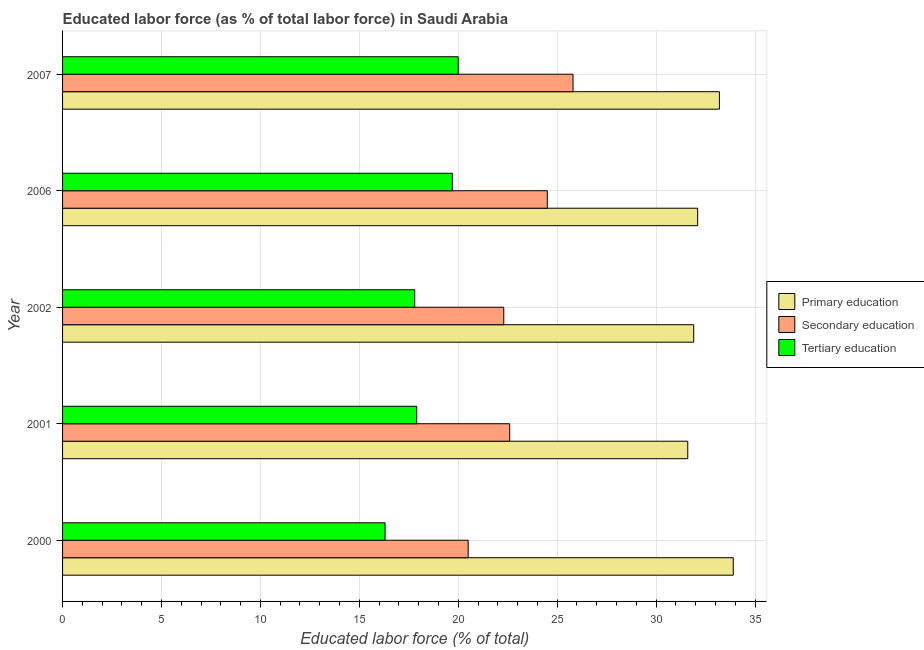Are the number of bars on each tick of the Y-axis equal?
Make the answer very short. Yes. How many bars are there on the 3rd tick from the bottom?
Offer a terse response. 3. In how many cases, is the number of bars for a given year not equal to the number of legend labels?
Offer a terse response. 0. What is the percentage of labor force who received secondary education in 2006?
Give a very brief answer. 24.5. Across all years, what is the maximum percentage of labor force who received secondary education?
Your answer should be very brief. 25.8. Across all years, what is the minimum percentage of labor force who received tertiary education?
Provide a succinct answer. 16.3. In which year was the percentage of labor force who received tertiary education minimum?
Your response must be concise. 2000. What is the total percentage of labor force who received secondary education in the graph?
Your answer should be compact. 115.7. What is the difference between the percentage of labor force who received tertiary education in 2000 and that in 2001?
Provide a succinct answer. -1.6. What is the difference between the percentage of labor force who received primary education in 2001 and the percentage of labor force who received tertiary education in 2007?
Your answer should be very brief. 11.6. What is the average percentage of labor force who received primary education per year?
Give a very brief answer. 32.54. In how many years, is the percentage of labor force who received primary education greater than 27 %?
Your answer should be very brief. 5. What is the ratio of the percentage of labor force who received tertiary education in 2001 to that in 2006?
Your response must be concise. 0.91. Is the difference between the percentage of labor force who received secondary education in 2001 and 2002 greater than the difference between the percentage of labor force who received tertiary education in 2001 and 2002?
Give a very brief answer. Yes. What is the difference between the highest and the second highest percentage of labor force who received primary education?
Offer a terse response. 0.7. What is the difference between the highest and the lowest percentage of labor force who received tertiary education?
Provide a succinct answer. 3.7. What does the 2nd bar from the top in 2002 represents?
Offer a terse response. Secondary education. What does the 3rd bar from the bottom in 2002 represents?
Provide a short and direct response. Tertiary education. Is it the case that in every year, the sum of the percentage of labor force who received primary education and percentage of labor force who received secondary education is greater than the percentage of labor force who received tertiary education?
Your answer should be compact. Yes. How many bars are there?
Keep it short and to the point. 15. What is the difference between two consecutive major ticks on the X-axis?
Offer a very short reply. 5. Are the values on the major ticks of X-axis written in scientific E-notation?
Ensure brevity in your answer.  No. Does the graph contain any zero values?
Your answer should be very brief. No. How many legend labels are there?
Your answer should be compact. 3. How are the legend labels stacked?
Ensure brevity in your answer.  Vertical. What is the title of the graph?
Ensure brevity in your answer.  Educated labor force (as % of total labor force) in Saudi Arabia. Does "Natural Gas" appear as one of the legend labels in the graph?
Your response must be concise. No. What is the label or title of the X-axis?
Offer a very short reply. Educated labor force (% of total). What is the label or title of the Y-axis?
Give a very brief answer. Year. What is the Educated labor force (% of total) of Primary education in 2000?
Your answer should be compact. 33.9. What is the Educated labor force (% of total) in Tertiary education in 2000?
Make the answer very short. 16.3. What is the Educated labor force (% of total) in Primary education in 2001?
Provide a succinct answer. 31.6. What is the Educated labor force (% of total) of Secondary education in 2001?
Give a very brief answer. 22.6. What is the Educated labor force (% of total) in Tertiary education in 2001?
Keep it short and to the point. 17.9. What is the Educated labor force (% of total) of Primary education in 2002?
Give a very brief answer. 31.9. What is the Educated labor force (% of total) in Secondary education in 2002?
Ensure brevity in your answer.  22.3. What is the Educated labor force (% of total) in Tertiary education in 2002?
Offer a terse response. 17.8. What is the Educated labor force (% of total) in Primary education in 2006?
Your answer should be very brief. 32.1. What is the Educated labor force (% of total) in Tertiary education in 2006?
Your response must be concise. 19.7. What is the Educated labor force (% of total) of Primary education in 2007?
Your response must be concise. 33.2. What is the Educated labor force (% of total) of Secondary education in 2007?
Your response must be concise. 25.8. Across all years, what is the maximum Educated labor force (% of total) of Primary education?
Offer a very short reply. 33.9. Across all years, what is the maximum Educated labor force (% of total) of Secondary education?
Your response must be concise. 25.8. Across all years, what is the maximum Educated labor force (% of total) of Tertiary education?
Your answer should be compact. 20. Across all years, what is the minimum Educated labor force (% of total) of Primary education?
Offer a very short reply. 31.6. Across all years, what is the minimum Educated labor force (% of total) in Secondary education?
Ensure brevity in your answer.  20.5. Across all years, what is the minimum Educated labor force (% of total) of Tertiary education?
Provide a succinct answer. 16.3. What is the total Educated labor force (% of total) in Primary education in the graph?
Offer a terse response. 162.7. What is the total Educated labor force (% of total) of Secondary education in the graph?
Give a very brief answer. 115.7. What is the total Educated labor force (% of total) in Tertiary education in the graph?
Your answer should be very brief. 91.7. What is the difference between the Educated labor force (% of total) of Tertiary education in 2000 and that in 2001?
Your answer should be very brief. -1.6. What is the difference between the Educated labor force (% of total) of Primary education in 2000 and that in 2002?
Offer a terse response. 2. What is the difference between the Educated labor force (% of total) in Primary education in 2000 and that in 2006?
Provide a succinct answer. 1.8. What is the difference between the Educated labor force (% of total) in Tertiary education in 2000 and that in 2006?
Keep it short and to the point. -3.4. What is the difference between the Educated labor force (% of total) of Primary education in 2000 and that in 2007?
Offer a terse response. 0.7. What is the difference between the Educated labor force (% of total) of Secondary education in 2000 and that in 2007?
Make the answer very short. -5.3. What is the difference between the Educated labor force (% of total) in Primary education in 2001 and that in 2002?
Provide a short and direct response. -0.3. What is the difference between the Educated labor force (% of total) of Secondary education in 2001 and that in 2002?
Offer a terse response. 0.3. What is the difference between the Educated labor force (% of total) of Tertiary education in 2001 and that in 2002?
Your response must be concise. 0.1. What is the difference between the Educated labor force (% of total) in Primary education in 2001 and that in 2006?
Keep it short and to the point. -0.5. What is the difference between the Educated labor force (% of total) in Primary education in 2001 and that in 2007?
Provide a short and direct response. -1.6. What is the difference between the Educated labor force (% of total) in Secondary education in 2001 and that in 2007?
Make the answer very short. -3.2. What is the difference between the Educated labor force (% of total) of Secondary education in 2002 and that in 2006?
Offer a terse response. -2.2. What is the difference between the Educated labor force (% of total) in Primary education in 2002 and that in 2007?
Your answer should be very brief. -1.3. What is the difference between the Educated labor force (% of total) of Secondary education in 2002 and that in 2007?
Offer a terse response. -3.5. What is the difference between the Educated labor force (% of total) in Secondary education in 2006 and that in 2007?
Make the answer very short. -1.3. What is the difference between the Educated labor force (% of total) in Tertiary education in 2006 and that in 2007?
Make the answer very short. -0.3. What is the difference between the Educated labor force (% of total) in Primary education in 2000 and the Educated labor force (% of total) in Secondary education in 2002?
Make the answer very short. 11.6. What is the difference between the Educated labor force (% of total) of Secondary education in 2000 and the Educated labor force (% of total) of Tertiary education in 2002?
Your answer should be compact. 2.7. What is the difference between the Educated labor force (% of total) in Primary education in 2000 and the Educated labor force (% of total) in Secondary education in 2006?
Your answer should be very brief. 9.4. What is the difference between the Educated labor force (% of total) in Secondary education in 2000 and the Educated labor force (% of total) in Tertiary education in 2006?
Your response must be concise. 0.8. What is the difference between the Educated labor force (% of total) of Primary education in 2000 and the Educated labor force (% of total) of Secondary education in 2007?
Provide a short and direct response. 8.1. What is the difference between the Educated labor force (% of total) in Primary education in 2000 and the Educated labor force (% of total) in Tertiary education in 2007?
Provide a short and direct response. 13.9. What is the difference between the Educated labor force (% of total) in Secondary education in 2000 and the Educated labor force (% of total) in Tertiary education in 2007?
Offer a terse response. 0.5. What is the difference between the Educated labor force (% of total) in Secondary education in 2001 and the Educated labor force (% of total) in Tertiary education in 2006?
Keep it short and to the point. 2.9. What is the difference between the Educated labor force (% of total) of Primary education in 2001 and the Educated labor force (% of total) of Secondary education in 2007?
Provide a short and direct response. 5.8. What is the difference between the Educated labor force (% of total) of Primary education in 2001 and the Educated labor force (% of total) of Tertiary education in 2007?
Your answer should be compact. 11.6. What is the difference between the Educated labor force (% of total) in Primary education in 2002 and the Educated labor force (% of total) in Tertiary education in 2006?
Provide a short and direct response. 12.2. What is the difference between the Educated labor force (% of total) of Secondary education in 2002 and the Educated labor force (% of total) of Tertiary education in 2007?
Your answer should be compact. 2.3. What is the difference between the Educated labor force (% of total) of Primary education in 2006 and the Educated labor force (% of total) of Tertiary education in 2007?
Offer a very short reply. 12.1. What is the difference between the Educated labor force (% of total) of Secondary education in 2006 and the Educated labor force (% of total) of Tertiary education in 2007?
Keep it short and to the point. 4.5. What is the average Educated labor force (% of total) of Primary education per year?
Offer a very short reply. 32.54. What is the average Educated labor force (% of total) of Secondary education per year?
Give a very brief answer. 23.14. What is the average Educated labor force (% of total) in Tertiary education per year?
Offer a terse response. 18.34. In the year 2000, what is the difference between the Educated labor force (% of total) of Primary education and Educated labor force (% of total) of Secondary education?
Offer a terse response. 13.4. In the year 2000, what is the difference between the Educated labor force (% of total) in Primary education and Educated labor force (% of total) in Tertiary education?
Provide a succinct answer. 17.6. In the year 2000, what is the difference between the Educated labor force (% of total) of Secondary education and Educated labor force (% of total) of Tertiary education?
Keep it short and to the point. 4.2. In the year 2001, what is the difference between the Educated labor force (% of total) of Primary education and Educated labor force (% of total) of Secondary education?
Provide a short and direct response. 9. In the year 2001, what is the difference between the Educated labor force (% of total) in Secondary education and Educated labor force (% of total) in Tertiary education?
Offer a terse response. 4.7. In the year 2002, what is the difference between the Educated labor force (% of total) of Primary education and Educated labor force (% of total) of Tertiary education?
Your answer should be very brief. 14.1. In the year 2006, what is the difference between the Educated labor force (% of total) in Primary education and Educated labor force (% of total) in Tertiary education?
Your answer should be very brief. 12.4. In the year 2006, what is the difference between the Educated labor force (% of total) of Secondary education and Educated labor force (% of total) of Tertiary education?
Your answer should be compact. 4.8. In the year 2007, what is the difference between the Educated labor force (% of total) in Secondary education and Educated labor force (% of total) in Tertiary education?
Provide a succinct answer. 5.8. What is the ratio of the Educated labor force (% of total) of Primary education in 2000 to that in 2001?
Your response must be concise. 1.07. What is the ratio of the Educated labor force (% of total) of Secondary education in 2000 to that in 2001?
Your answer should be compact. 0.91. What is the ratio of the Educated labor force (% of total) in Tertiary education in 2000 to that in 2001?
Provide a succinct answer. 0.91. What is the ratio of the Educated labor force (% of total) in Primary education in 2000 to that in 2002?
Your answer should be compact. 1.06. What is the ratio of the Educated labor force (% of total) of Secondary education in 2000 to that in 2002?
Your response must be concise. 0.92. What is the ratio of the Educated labor force (% of total) in Tertiary education in 2000 to that in 2002?
Your response must be concise. 0.92. What is the ratio of the Educated labor force (% of total) of Primary education in 2000 to that in 2006?
Ensure brevity in your answer.  1.06. What is the ratio of the Educated labor force (% of total) in Secondary education in 2000 to that in 2006?
Make the answer very short. 0.84. What is the ratio of the Educated labor force (% of total) of Tertiary education in 2000 to that in 2006?
Your answer should be very brief. 0.83. What is the ratio of the Educated labor force (% of total) in Primary education in 2000 to that in 2007?
Provide a short and direct response. 1.02. What is the ratio of the Educated labor force (% of total) of Secondary education in 2000 to that in 2007?
Ensure brevity in your answer.  0.79. What is the ratio of the Educated labor force (% of total) in Tertiary education in 2000 to that in 2007?
Offer a terse response. 0.81. What is the ratio of the Educated labor force (% of total) of Primary education in 2001 to that in 2002?
Offer a very short reply. 0.99. What is the ratio of the Educated labor force (% of total) of Secondary education in 2001 to that in 2002?
Ensure brevity in your answer.  1.01. What is the ratio of the Educated labor force (% of total) of Tertiary education in 2001 to that in 2002?
Keep it short and to the point. 1.01. What is the ratio of the Educated labor force (% of total) in Primary education in 2001 to that in 2006?
Your answer should be very brief. 0.98. What is the ratio of the Educated labor force (% of total) of Secondary education in 2001 to that in 2006?
Provide a succinct answer. 0.92. What is the ratio of the Educated labor force (% of total) in Tertiary education in 2001 to that in 2006?
Offer a terse response. 0.91. What is the ratio of the Educated labor force (% of total) in Primary education in 2001 to that in 2007?
Provide a succinct answer. 0.95. What is the ratio of the Educated labor force (% of total) of Secondary education in 2001 to that in 2007?
Give a very brief answer. 0.88. What is the ratio of the Educated labor force (% of total) in Tertiary education in 2001 to that in 2007?
Your answer should be very brief. 0.9. What is the ratio of the Educated labor force (% of total) in Primary education in 2002 to that in 2006?
Provide a short and direct response. 0.99. What is the ratio of the Educated labor force (% of total) of Secondary education in 2002 to that in 2006?
Provide a short and direct response. 0.91. What is the ratio of the Educated labor force (% of total) of Tertiary education in 2002 to that in 2006?
Ensure brevity in your answer.  0.9. What is the ratio of the Educated labor force (% of total) of Primary education in 2002 to that in 2007?
Offer a terse response. 0.96. What is the ratio of the Educated labor force (% of total) of Secondary education in 2002 to that in 2007?
Your answer should be very brief. 0.86. What is the ratio of the Educated labor force (% of total) in Tertiary education in 2002 to that in 2007?
Ensure brevity in your answer.  0.89. What is the ratio of the Educated labor force (% of total) in Primary education in 2006 to that in 2007?
Give a very brief answer. 0.97. What is the ratio of the Educated labor force (% of total) in Secondary education in 2006 to that in 2007?
Your response must be concise. 0.95. What is the ratio of the Educated labor force (% of total) in Tertiary education in 2006 to that in 2007?
Offer a very short reply. 0.98. What is the difference between the highest and the second highest Educated labor force (% of total) in Secondary education?
Offer a very short reply. 1.3. What is the difference between the highest and the second highest Educated labor force (% of total) in Tertiary education?
Offer a terse response. 0.3. What is the difference between the highest and the lowest Educated labor force (% of total) of Primary education?
Offer a terse response. 2.3. 